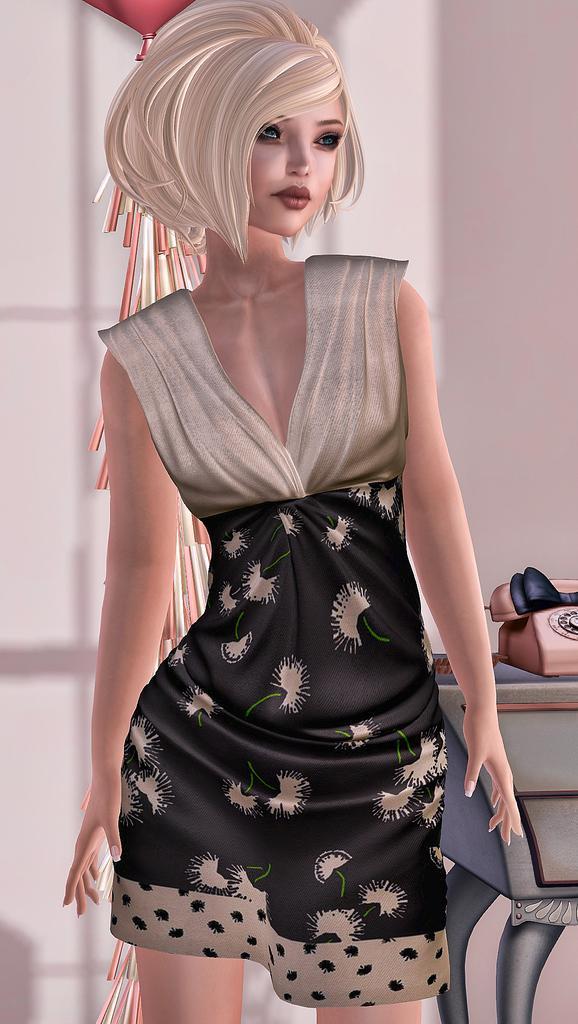In one or two sentences, can you explain what this image depicts? This is an animated image, we can see there is one picture of a woman in the middle of this image, and there is a telephone kept on a table on the right side of this image, and there is a wall in the background. 